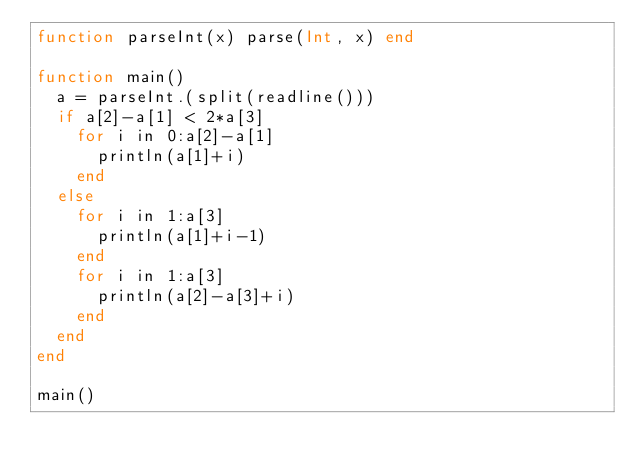Convert code to text. <code><loc_0><loc_0><loc_500><loc_500><_Julia_>function parseInt(x) parse(Int, x) end

function main()
	a = parseInt.(split(readline()))
	if a[2]-a[1] < 2*a[3]
		for i in 0:a[2]-a[1]
			println(a[1]+i)
		end
	else
		for i in 1:a[3]
			println(a[1]+i-1)
		end
		for i in 1:a[3]
			println(a[2]-a[3]+i)
		end
	end
end

main()</code> 